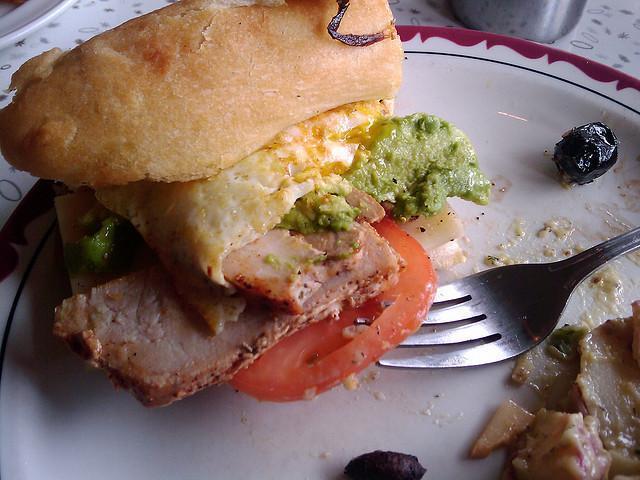Is the caption "The broccoli is within the sandwich." a true representation of the image?
Answer yes or no. Yes. 